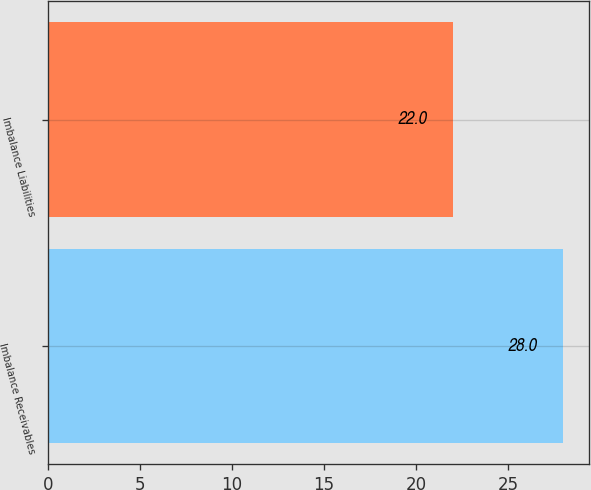Convert chart to OTSL. <chart><loc_0><loc_0><loc_500><loc_500><bar_chart><fcel>Imbalance Receivables<fcel>Imbalance Liabilities<nl><fcel>28<fcel>22<nl></chart> 